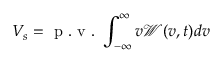Convert formula to latex. <formula><loc_0><loc_0><loc_500><loc_500>V _ { s } = p . v . \int _ { - \infty } ^ { \infty } v \mathcal { W } ( v , t ) d v</formula> 